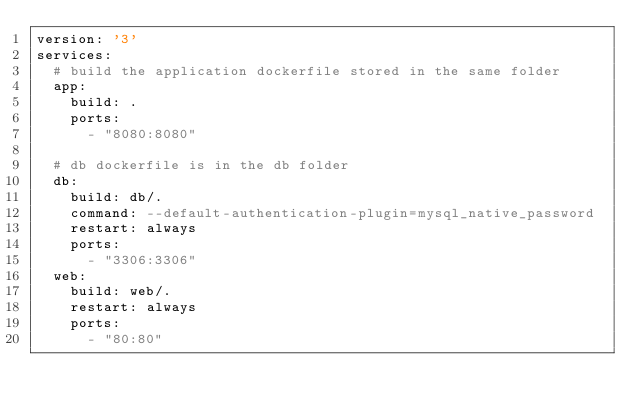<code> <loc_0><loc_0><loc_500><loc_500><_YAML_>version: '3'
services:
  # build the application dockerfile stored in the same folder
  app:
    build: .
    ports:
      - "8080:8080"

  # db dockerfile is in the db folder
  db:
    build: db/.
    command: --default-authentication-plugin=mysql_native_password
    restart: always
    ports:
      - "3306:3306"
  web:
    build: web/.
    restart: always
    ports:
      - "80:80"</code> 